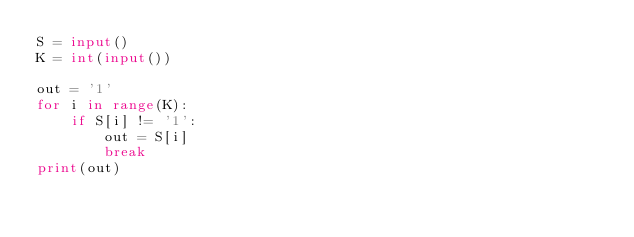Convert code to text. <code><loc_0><loc_0><loc_500><loc_500><_Python_>S = input()
K = int(input())

out = '1'
for i in range(K):
    if S[i] != '1':
        out = S[i]
        break
print(out)</code> 